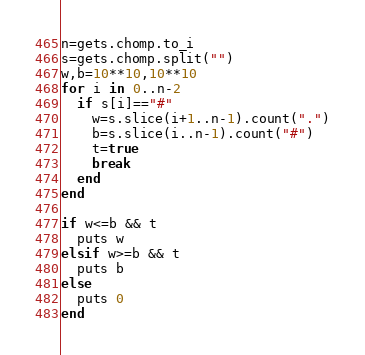<code> <loc_0><loc_0><loc_500><loc_500><_Ruby_>n=gets.chomp.to_i
s=gets.chomp.split("")
w,b=10**10,10**10
for i in 0..n-2
  if s[i]=="#"
    w=s.slice(i+1..n-1).count(".")
    b=s.slice(i..n-1).count("#")
    t=true
    break
  end
end

if w<=b && t
  puts w
elsif w>=b && t
  puts b
else
  puts 0
end</code> 